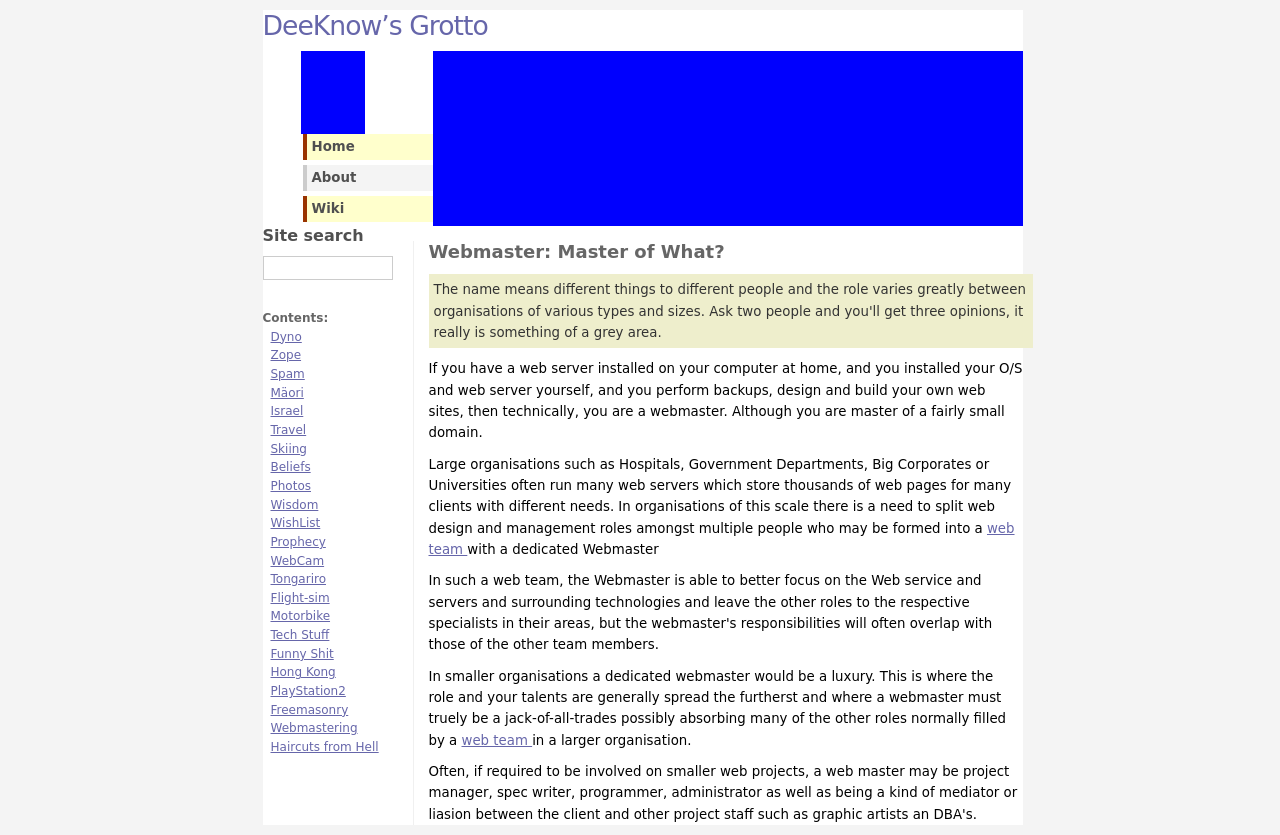What is the purpose of side menus in web design as shown in the screenshot? Side menus, like the one in the screenshot, are used for navigation purposes, providing easy access to various sections of the website. They help users locate and move between different content areas efficiently, improving the overall usability and experience. They can host links to important pages such as Home, About, Contact, or specific topics like the website's blog or services sections. 